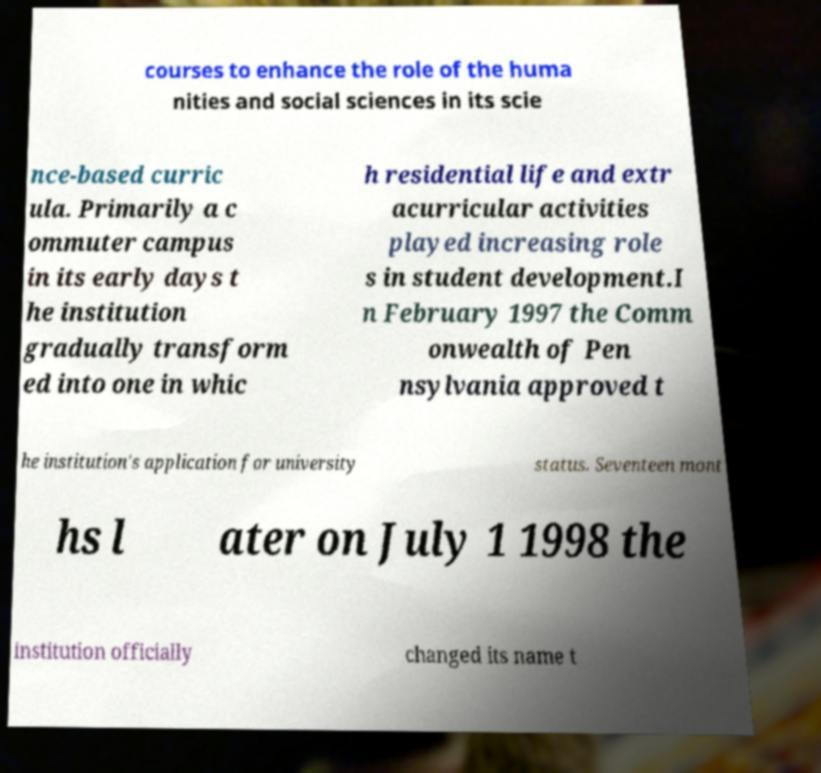Can you accurately transcribe the text from the provided image for me? courses to enhance the role of the huma nities and social sciences in its scie nce-based curric ula. Primarily a c ommuter campus in its early days t he institution gradually transform ed into one in whic h residential life and extr acurricular activities played increasing role s in student development.I n February 1997 the Comm onwealth of Pen nsylvania approved t he institution's application for university status. Seventeen mont hs l ater on July 1 1998 the institution officially changed its name t 